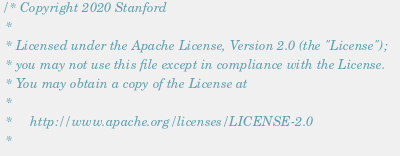<code> <loc_0><loc_0><loc_500><loc_500><_Cuda_>/* Copyright 2020 Stanford
 *
 * Licensed under the Apache License, Version 2.0 (the "License");
 * you may not use this file except in compliance with the License.
 * You may obtain a copy of the License at
 *
 *     http://www.apache.org/licenses/LICENSE-2.0
 *</code> 